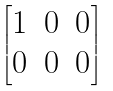Convert formula to latex. <formula><loc_0><loc_0><loc_500><loc_500>\begin{bmatrix} 1 & 0 & 0 \\ 0 & 0 & 0 \end{bmatrix}</formula> 